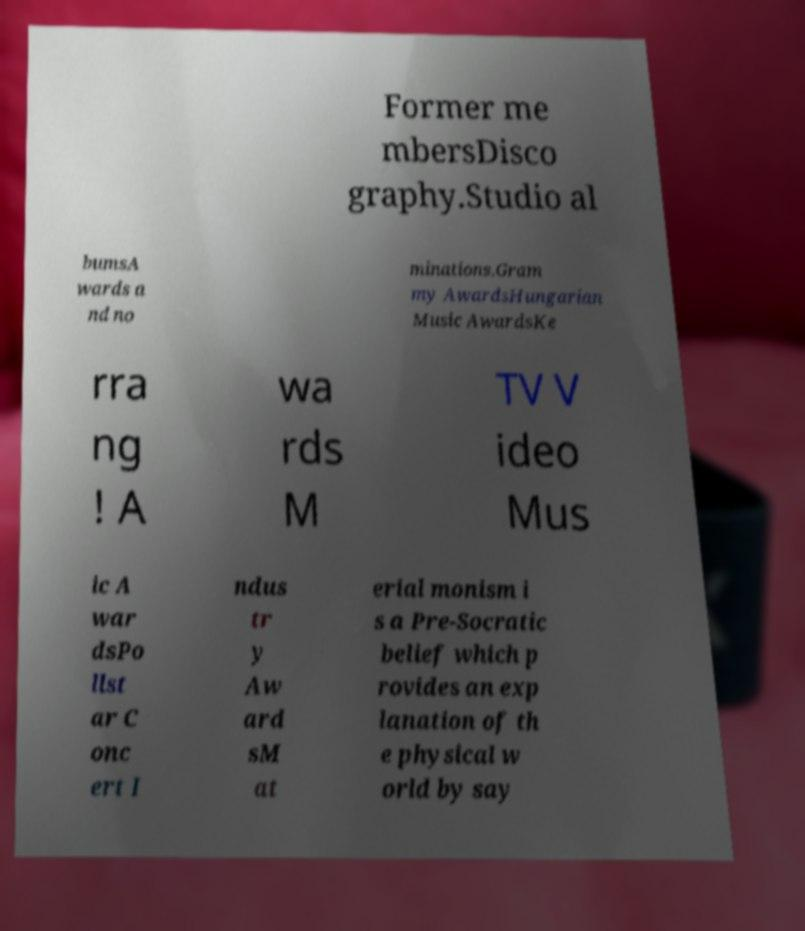Can you accurately transcribe the text from the provided image for me? Former me mbersDisco graphy.Studio al bumsA wards a nd no minations.Gram my AwardsHungarian Music AwardsKe rra ng ! A wa rds M TV V ideo Mus ic A war dsPo llst ar C onc ert I ndus tr y Aw ard sM at erial monism i s a Pre-Socratic belief which p rovides an exp lanation of th e physical w orld by say 